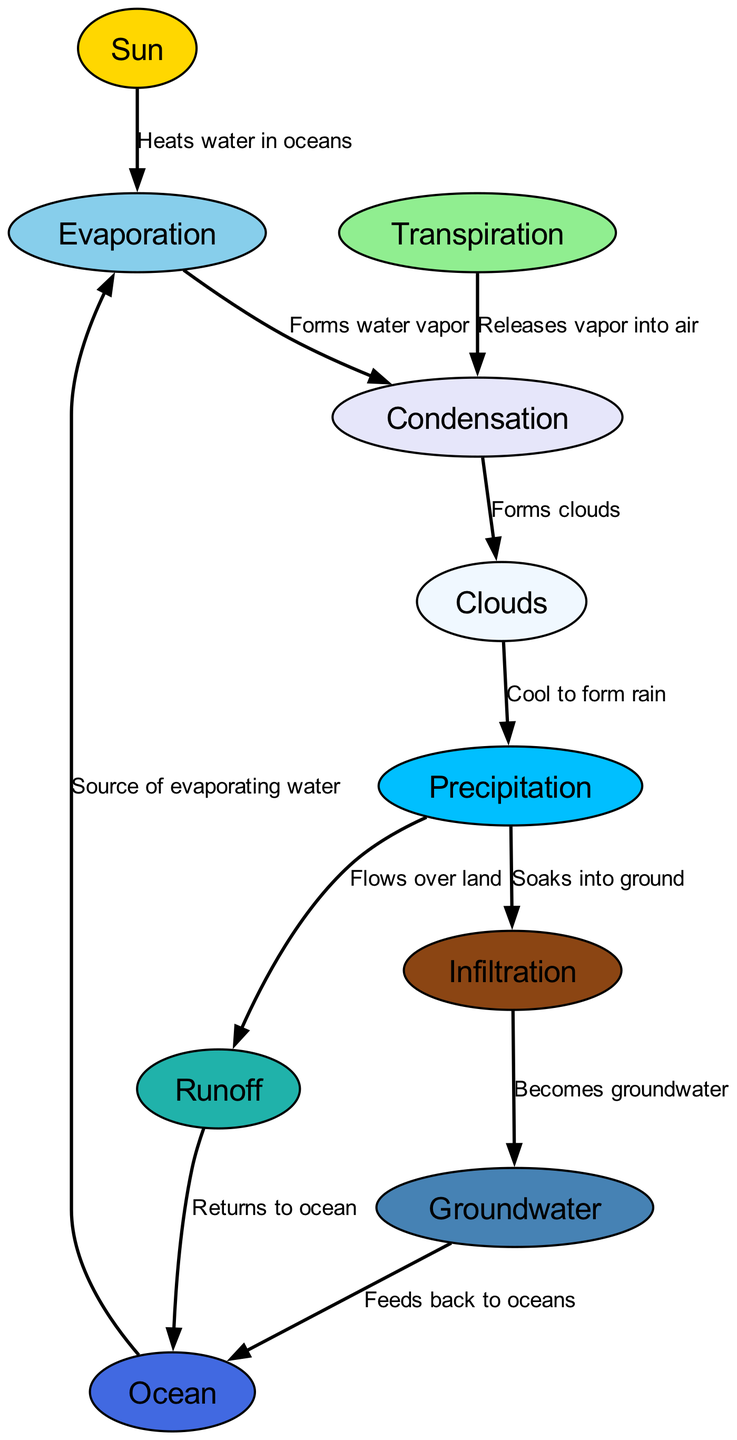What is the primary source of energy for the water cycle? The diagram shows a node labeled "Sun," which is described as "The primary source of energy for the water cycle." This indicates that the Sun provides the necessary energy for the processes within the water cycle.
Answer: Sun How many nodes are there in the diagram? By counting the entries in the "nodes" section of the data, we find there are ten nodes representing different components of the water cycle.
Answer: 10 Which process follows Evaporation in the water cycle? The diagram shows that after "Evaporation," the next process is "Condensation," as indicated by the directed edge from Evaporation to Condensation. The flow of the diagram illustrates this progression clearly.
Answer: Condensation What is released into the atmosphere during Transpiration? According to the description of the "Transpiration" node, it states that water vapor is released from plants, which is the primary detail depicted in the node.
Answer: Water vapor What occurs after Clouds in the water cycle? The diagram indicates that after the "Clouds" node, the next step is "Precipitation," where clouds cool to form rain and other forms of water falling from the atmosphere. Therefore, this is how the flow moves after clouds.
Answer: Precipitation What happens to the water after it precipitates? From the "Precipitation" node, the diagram leads to two outcomes: "Runoff" (water flowing over land) and "Infiltration" (water soaking into the ground). This dual path indicates two fates for precipitated water.
Answer: Runoff and Infiltration What is the relationship between Groundwater and Ocean? The diagram shows a directed edge from "Groundwater" to "Ocean," indicating that groundwater eventually feeds back into oceans. This reinforces the connectivity between these two components of the water cycle.
Answer: Feeds back to ocean How does water vapor become Clouds? The diagram illustrates that water vapor cools to form clouds, which is represented by the edge from "Condensation" to "Clouds." This transition is crucial as it depicts how the vapor transforms into a visible form in the atmosphere.
Answer: Cools to form clouds Which component is the largest reservoir of water on Earth? The diagram identifies the "Ocean" as the largest reservoir of water on Earth, based on the description provided for that node.
Answer: Ocean 